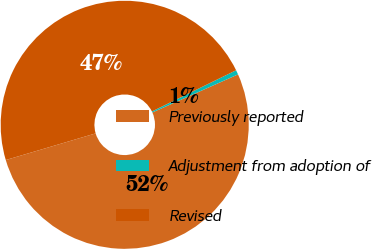Convert chart. <chart><loc_0><loc_0><loc_500><loc_500><pie_chart><fcel>Previously reported<fcel>Adjustment from adoption of<fcel>Revised<nl><fcel>52.07%<fcel>0.59%<fcel>47.34%<nl></chart> 